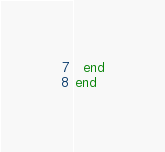Convert code to text. <code><loc_0><loc_0><loc_500><loc_500><_Crystal_>  end
end
</code> 